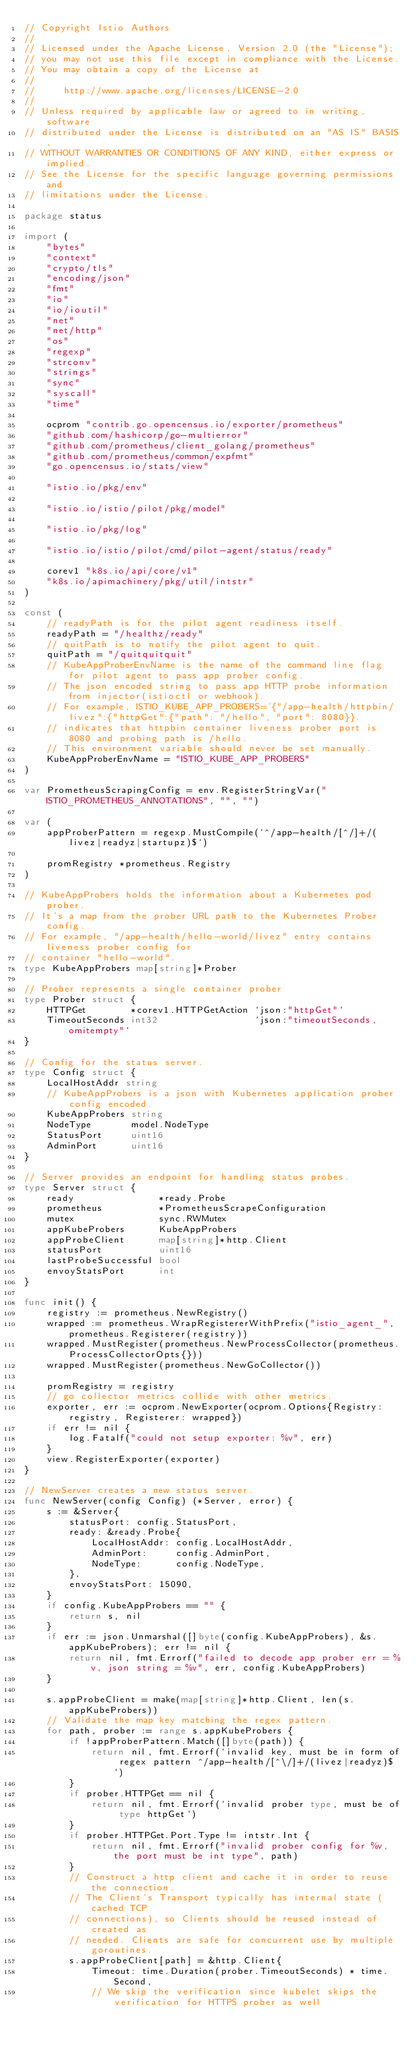Convert code to text. <code><loc_0><loc_0><loc_500><loc_500><_Go_>// Copyright Istio Authors
//
// Licensed under the Apache License, Version 2.0 (the "License");
// you may not use this file except in compliance with the License.
// You may obtain a copy of the License at
//
//     http://www.apache.org/licenses/LICENSE-2.0
//
// Unless required by applicable law or agreed to in writing, software
// distributed under the License is distributed on an "AS IS" BASIS,
// WITHOUT WARRANTIES OR CONDITIONS OF ANY KIND, either express or implied.
// See the License for the specific language governing permissions and
// limitations under the License.

package status

import (
	"bytes"
	"context"
	"crypto/tls"
	"encoding/json"
	"fmt"
	"io"
	"io/ioutil"
	"net"
	"net/http"
	"os"
	"regexp"
	"strconv"
	"strings"
	"sync"
	"syscall"
	"time"

	ocprom "contrib.go.opencensus.io/exporter/prometheus"
	"github.com/hashicorp/go-multierror"
	"github.com/prometheus/client_golang/prometheus"
	"github.com/prometheus/common/expfmt"
	"go.opencensus.io/stats/view"

	"istio.io/pkg/env"

	"istio.io/istio/pilot/pkg/model"

	"istio.io/pkg/log"

	"istio.io/istio/pilot/cmd/pilot-agent/status/ready"

	corev1 "k8s.io/api/core/v1"
	"k8s.io/apimachinery/pkg/util/intstr"
)

const (
	// readyPath is for the pilot agent readiness itself.
	readyPath = "/healthz/ready"
	// quitPath is to notify the pilot agent to quit.
	quitPath = "/quitquitquit"
	// KubeAppProberEnvName is the name of the command line flag for pilot agent to pass app prober config.
	// The json encoded string to pass app HTTP probe information from injector(istioctl or webhook).
	// For example, ISTIO_KUBE_APP_PROBERS='{"/app-health/httpbin/livez":{"httpGet":{"path": "/hello", "port": 8080}}.
	// indicates that httpbin container liveness prober port is 8080 and probing path is /hello.
	// This environment variable should never be set manually.
	KubeAppProberEnvName = "ISTIO_KUBE_APP_PROBERS"
)

var PrometheusScrapingConfig = env.RegisterStringVar("ISTIO_PROMETHEUS_ANNOTATIONS", "", "")

var (
	appProberPattern = regexp.MustCompile(`^/app-health/[^/]+/(livez|readyz|startupz)$`)

	promRegistry *prometheus.Registry
)

// KubeAppProbers holds the information about a Kubernetes pod prober.
// It's a map from the prober URL path to the Kubernetes Prober config.
// For example, "/app-health/hello-world/livez" entry contains liveness prober config for
// container "hello-world".
type KubeAppProbers map[string]*Prober

// Prober represents a single container prober
type Prober struct {
	HTTPGet        *corev1.HTTPGetAction `json:"httpGet"`
	TimeoutSeconds int32                 `json:"timeoutSeconds,omitempty"`
}

// Config for the status server.
type Config struct {
	LocalHostAddr string
	// KubeAppProbers is a json with Kubernetes application prober config encoded.
	KubeAppProbers string
	NodeType       model.NodeType
	StatusPort     uint16
	AdminPort      uint16
}

// Server provides an endpoint for handling status probes.
type Server struct {
	ready               *ready.Probe
	prometheus          *PrometheusScrapeConfiguration
	mutex               sync.RWMutex
	appKubeProbers      KubeAppProbers
	appProbeClient      map[string]*http.Client
	statusPort          uint16
	lastProbeSuccessful bool
	envoyStatsPort      int
}

func init() {
	registry := prometheus.NewRegistry()
	wrapped := prometheus.WrapRegistererWithPrefix("istio_agent_", prometheus.Registerer(registry))
	wrapped.MustRegister(prometheus.NewProcessCollector(prometheus.ProcessCollectorOpts{}))
	wrapped.MustRegister(prometheus.NewGoCollector())

	promRegistry = registry
	// go collector metrics collide with other metrics.
	exporter, err := ocprom.NewExporter(ocprom.Options{Registry: registry, Registerer: wrapped})
	if err != nil {
		log.Fatalf("could not setup exporter: %v", err)
	}
	view.RegisterExporter(exporter)
}

// NewServer creates a new status server.
func NewServer(config Config) (*Server, error) {
	s := &Server{
		statusPort: config.StatusPort,
		ready: &ready.Probe{
			LocalHostAddr: config.LocalHostAddr,
			AdminPort:     config.AdminPort,
			NodeType:      config.NodeType,
		},
		envoyStatsPort: 15090,
	}
	if config.KubeAppProbers == "" {
		return s, nil
	}
	if err := json.Unmarshal([]byte(config.KubeAppProbers), &s.appKubeProbers); err != nil {
		return nil, fmt.Errorf("failed to decode app prober err = %v, json string = %v", err, config.KubeAppProbers)
	}

	s.appProbeClient = make(map[string]*http.Client, len(s.appKubeProbers))
	// Validate the map key matching the regex pattern.
	for path, prober := range s.appKubeProbers {
		if !appProberPattern.Match([]byte(path)) {
			return nil, fmt.Errorf(`invalid key, must be in form of regex pattern ^/app-health/[^\/]+/(livez|readyz)$`)
		}
		if prober.HTTPGet == nil {
			return nil, fmt.Errorf(`invalid prober type, must be of type httpGet`)
		}
		if prober.HTTPGet.Port.Type != intstr.Int {
			return nil, fmt.Errorf("invalid prober config for %v, the port must be int type", path)
		}
		// Construct a http client and cache it in order to reuse the connection.
		// The Client's Transport typically has internal state (cached TCP
		// connections), so Clients should be reused instead of created as
		// needed. Clients are safe for concurrent use by multiple goroutines.
		s.appProbeClient[path] = &http.Client{
			Timeout: time.Duration(prober.TimeoutSeconds) * time.Second,
			// We skip the verification since kubelet skips the verification for HTTPS prober as well</code> 